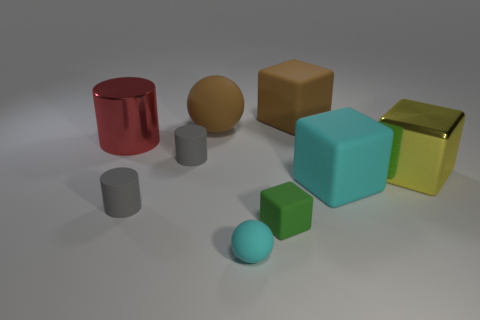What color is the other matte object that is the same shape as the tiny cyan thing?
Keep it short and to the point. Brown. The big cylinder that is made of the same material as the yellow block is what color?
Your answer should be very brief. Red. How big is the brown rubber ball?
Keep it short and to the point. Large. There is a cube on the right side of the big cyan cube; what is its material?
Your response must be concise. Metal. What material is the red thing that is the same size as the cyan cube?
Your answer should be very brief. Metal. What is the material of the large thing that is to the left of the brown thing left of the rubber ball that is in front of the large yellow thing?
Your answer should be very brief. Metal. There is a green rubber cube in front of the metallic cylinder; is it the same size as the large brown matte ball?
Your answer should be compact. No. Are there more cyan metal blocks than large red shiny cylinders?
Provide a succinct answer. No. How many big objects are either metallic cylinders or red metal blocks?
Give a very brief answer. 1. How many other objects are there of the same color as the tiny block?
Ensure brevity in your answer.  0. 